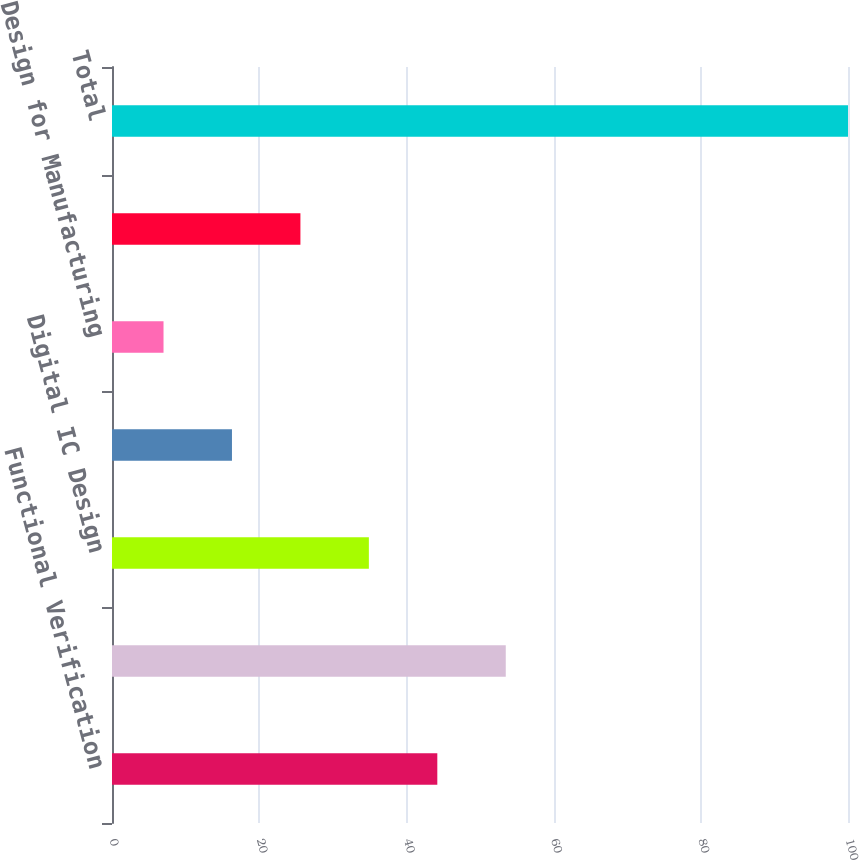Convert chart. <chart><loc_0><loc_0><loc_500><loc_500><bar_chart><fcel>Functional Verification<fcel>Custom IC Design<fcel>Digital IC Design<fcel>System Interconnect Design<fcel>Design for Manufacturing<fcel>Services and other<fcel>Total<nl><fcel>44.2<fcel>53.5<fcel>34.9<fcel>16.3<fcel>7<fcel>25.6<fcel>100<nl></chart> 